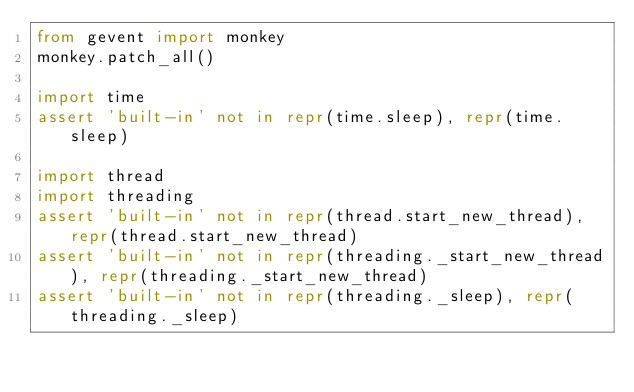Convert code to text. <code><loc_0><loc_0><loc_500><loc_500><_Python_>from gevent import monkey
monkey.patch_all()

import time
assert 'built-in' not in repr(time.sleep), repr(time.sleep)

import thread
import threading
assert 'built-in' not in repr(thread.start_new_thread), repr(thread.start_new_thread)
assert 'built-in' not in repr(threading._start_new_thread), repr(threading._start_new_thread)
assert 'built-in' not in repr(threading._sleep), repr(threading._sleep)
</code> 